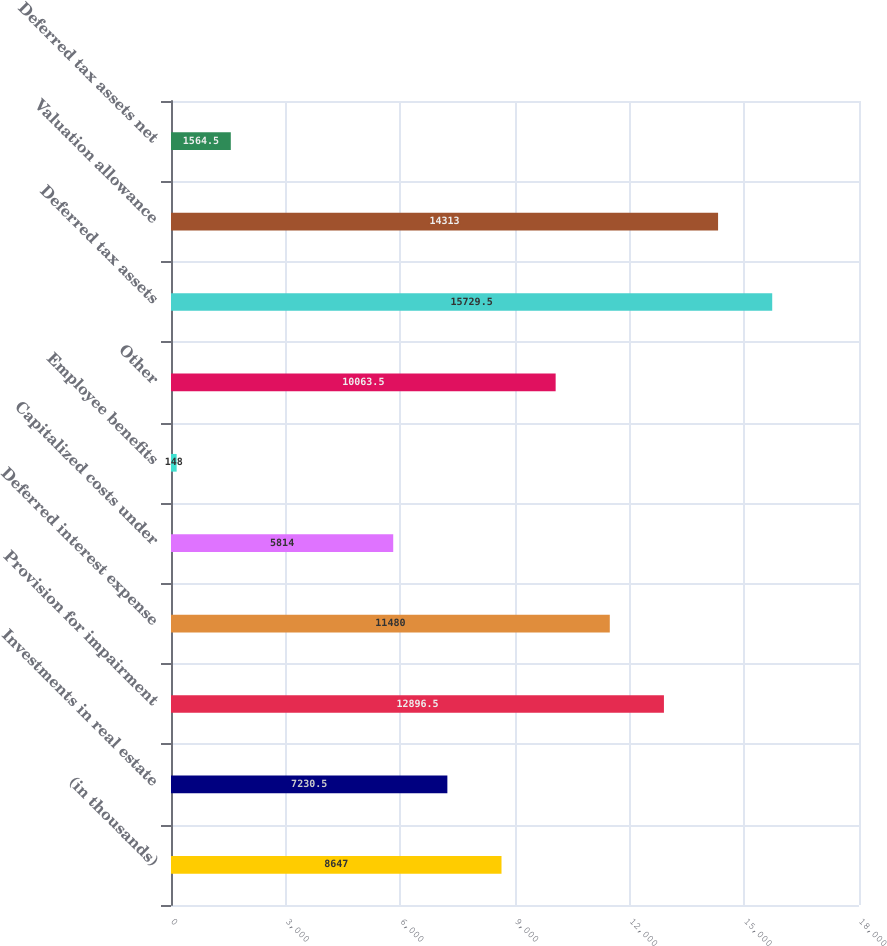Convert chart. <chart><loc_0><loc_0><loc_500><loc_500><bar_chart><fcel>(in thousands)<fcel>Investments in real estate<fcel>Provision for impairment<fcel>Deferred interest expense<fcel>Capitalized costs under<fcel>Employee benefits<fcel>Other<fcel>Deferred tax assets<fcel>Valuation allowance<fcel>Deferred tax assets net<nl><fcel>8647<fcel>7230.5<fcel>12896.5<fcel>11480<fcel>5814<fcel>148<fcel>10063.5<fcel>15729.5<fcel>14313<fcel>1564.5<nl></chart> 